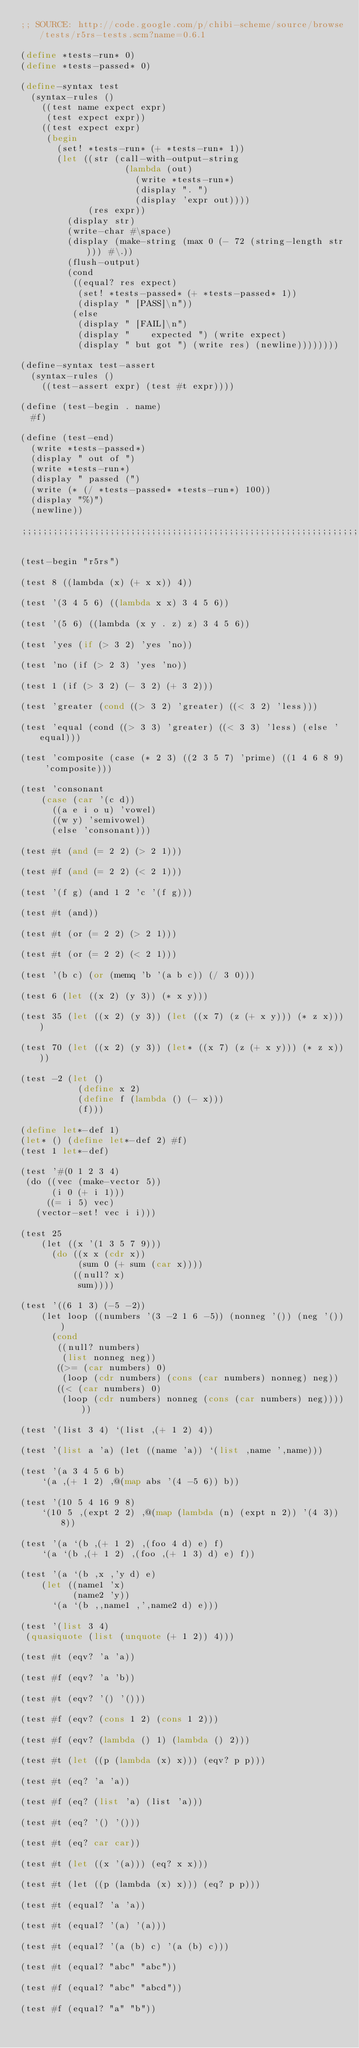Convert code to text. <code><loc_0><loc_0><loc_500><loc_500><_Scheme_>;; SOURCE: http://code.google.com/p/chibi-scheme/source/browse/tests/r5rs-tests.scm?name=0.6.1

(define *tests-run* 0)
(define *tests-passed* 0)

(define-syntax test
  (syntax-rules ()
    ((test name expect expr)
     (test expect expr))
    ((test expect expr)
     (begin
       (set! *tests-run* (+ *tests-run* 1))
       (let ((str (call-with-output-string
                    (lambda (out)
                      (write *tests-run*)
                      (display ". ")
                      (display 'expr out))))
             (res expr))
         (display str)
         (write-char #\space)
         (display (make-string (max 0 (- 72 (string-length str))) #\.))
         (flush-output)
         (cond
          ((equal? res expect)
           (set! *tests-passed* (+ *tests-passed* 1))
           (display " [PASS]\n"))
          (else
           (display " [FAIL]\n")
           (display "    expected ") (write expect)
           (display " but got ") (write res) (newline))))))))

(define-syntax test-assert
  (syntax-rules ()
    ((test-assert expr) (test #t expr))))

(define (test-begin . name)
  #f)

(define (test-end)
  (write *tests-passed*)
  (display " out of ")
  (write *tests-run*)
  (display " passed (")
  (write (* (/ *tests-passed* *tests-run*) 100))
  (display "%)")
  (newline))

;;;;;;;;;;;;;;;;;;;;;;;;;;;;;;;;;;;;;;;;;;;;;;;;;;;;;;;;;;;;;;;;;;;;;;;;

(test-begin "r5rs")

(test 8 ((lambda (x) (+ x x)) 4))

(test '(3 4 5 6) ((lambda x x) 3 4 5 6))

(test '(5 6) ((lambda (x y . z) z) 3 4 5 6))

(test 'yes (if (> 3 2) 'yes 'no))

(test 'no (if (> 2 3) 'yes 'no))

(test 1 (if (> 3 2) (- 3 2) (+ 3 2)))

(test 'greater (cond ((> 3 2) 'greater) ((< 3 2) 'less)))

(test 'equal (cond ((> 3 3) 'greater) ((< 3 3) 'less) (else 'equal)))

(test 'composite (case (* 2 3) ((2 3 5 7) 'prime) ((1 4 6 8 9) 'composite)))

(test 'consonant
    (case (car '(c d))
      ((a e i o u) 'vowel)
      ((w y) 'semivowel)
      (else 'consonant)))

(test #t (and (= 2 2) (> 2 1)))

(test #f (and (= 2 2) (< 2 1)))

(test '(f g) (and 1 2 'c '(f g)))

(test #t (and))

(test #t (or (= 2 2) (> 2 1)))

(test #t (or (= 2 2) (< 2 1)))

(test '(b c) (or (memq 'b '(a b c)) (/ 3 0)))

(test 6 (let ((x 2) (y 3)) (* x y)))

(test 35 (let ((x 2) (y 3)) (let ((x 7) (z (+ x y))) (* z x))))

(test 70 (let ((x 2) (y 3)) (let* ((x 7) (z (+ x y))) (* z x))))

(test -2 (let ()
           (define x 2)
           (define f (lambda () (- x)))
           (f)))

(define let*-def 1)
(let* () (define let*-def 2) #f)
(test 1 let*-def)

(test '#(0 1 2 3 4)
 (do ((vec (make-vector 5))
      (i 0 (+ i 1)))
     ((= i 5) vec)
   (vector-set! vec i i)))

(test 25
    (let ((x '(1 3 5 7 9)))
      (do ((x x (cdr x))
           (sum 0 (+ sum (car x))))
          ((null? x)
           sum))))

(test '((6 1 3) (-5 -2))
    (let loop ((numbers '(3 -2 1 6 -5)) (nonneg '()) (neg '()))
      (cond
       ((null? numbers)
        (list nonneg neg))
       ((>= (car numbers) 0)
        (loop (cdr numbers) (cons (car numbers) nonneg) neg))
       ((< (car numbers) 0)
        (loop (cdr numbers) nonneg (cons (car numbers) neg))))))

(test '(list 3 4) `(list ,(+ 1 2) 4))

(test '(list a 'a) (let ((name 'a)) `(list ,name ',name)))

(test '(a 3 4 5 6 b)
    `(a ,(+ 1 2) ,@(map abs '(4 -5 6)) b))

(test '(10 5 4 16 9 8)
    `(10 5 ,(expt 2 2) ,@(map (lambda (n) (expt n 2)) '(4 3)) 8))

(test '(a `(b ,(+ 1 2) ,(foo 4 d) e) f)
    `(a `(b ,(+ 1 2) ,(foo ,(+ 1 3) d) e) f))

(test '(a `(b ,x ,'y d) e)
    (let ((name1 'x)
          (name2 'y))
      `(a `(b ,,name1 ,',name2 d) e)))

(test '(list 3 4)
 (quasiquote (list (unquote (+ 1 2)) 4)))

(test #t (eqv? 'a 'a))

(test #f (eqv? 'a 'b))

(test #t (eqv? '() '()))

(test #f (eqv? (cons 1 2) (cons 1 2)))

(test #f (eqv? (lambda () 1) (lambda () 2)))

(test #t (let ((p (lambda (x) x))) (eqv? p p)))

(test #t (eq? 'a 'a))

(test #f (eq? (list 'a) (list 'a)))

(test #t (eq? '() '()))

(test #t (eq? car car))

(test #t (let ((x '(a))) (eq? x x)))

(test #t (let ((p (lambda (x) x))) (eq? p p)))

(test #t (equal? 'a 'a))

(test #t (equal? '(a) '(a)))

(test #t (equal? '(a (b) c) '(a (b) c)))

(test #t (equal? "abc" "abc"))

(test #f (equal? "abc" "abcd"))

(test #f (equal? "a" "b"))
</code> 